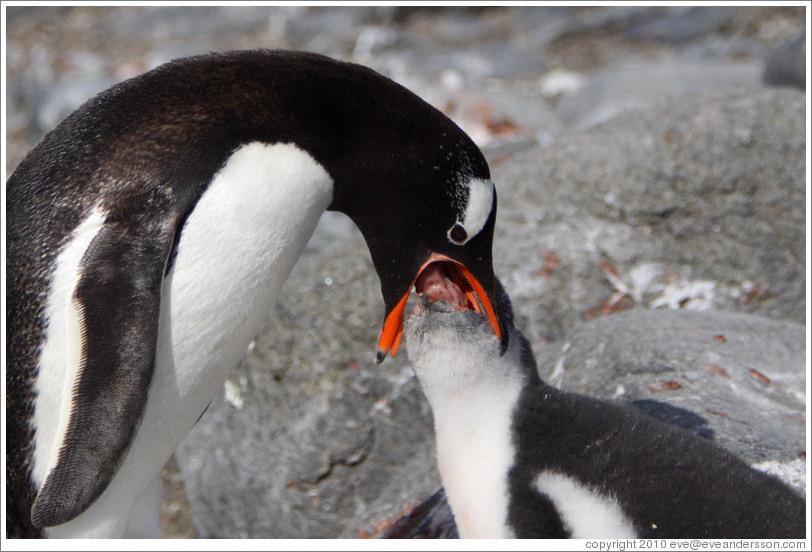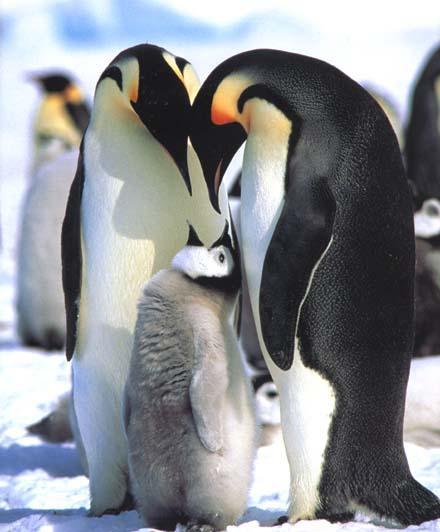The first image is the image on the left, the second image is the image on the right. For the images displayed, is the sentence "An image shows a penguin poking its mostly closed beak in the fuzzy feathers of another penguin." factually correct? Answer yes or no. No. 